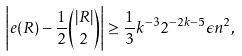Convert formula to latex. <formula><loc_0><loc_0><loc_500><loc_500>\left | e ( R ) - \frac { 1 } { 2 } { | R | \choose 2 } \right | \geq \frac { 1 } { 3 } k ^ { - 3 } 2 ^ { - 2 k - 5 } \epsilon n ^ { 2 } ,</formula> 